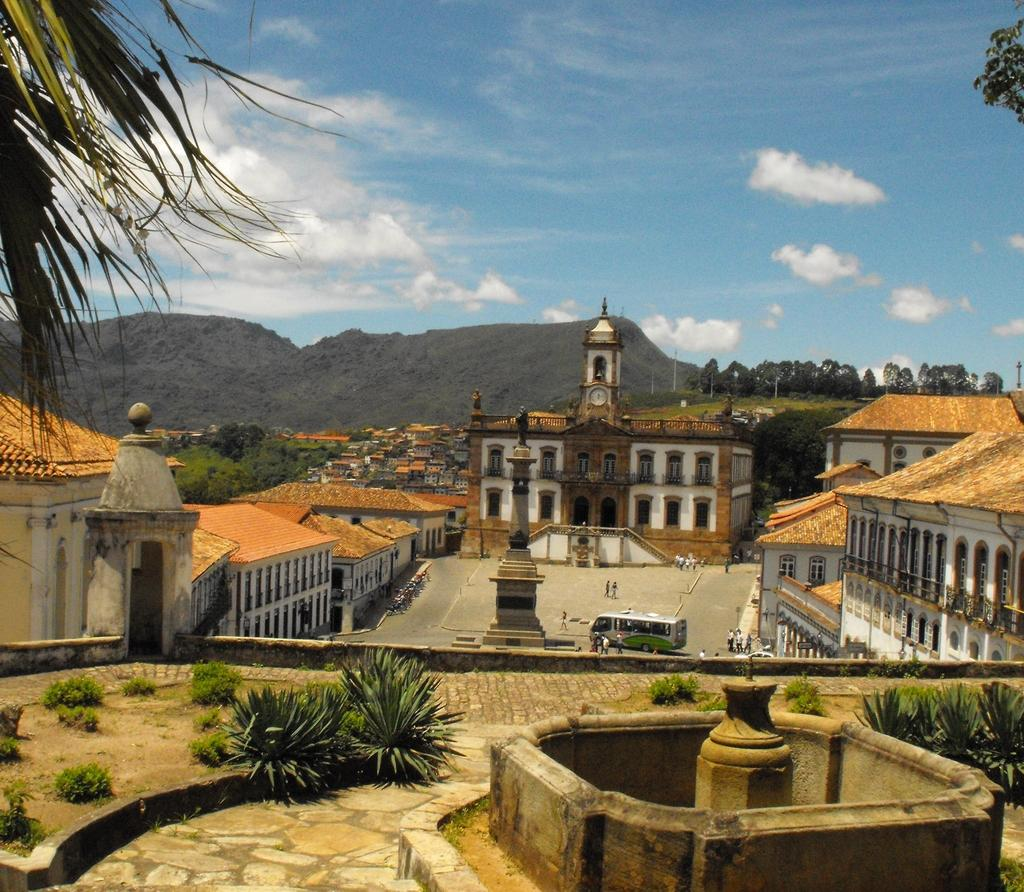What types of structures can be seen in the image? There are buildings in the image. What natural elements are present? There are plants, trees, and sky visible in the image. Can you describe any other objects in the image? There are other objects in the image, but their specific details are not mentioned in the facts. Are there any people visible in the image? Yes, there are people in the background of the image. What else can be seen in the background of the image? There is a bus and other objects visible in the background of the image. What question is being asked by the kittens in the image? There are no kittens present in the image, so no such question can be asked. What is the purpose of the bus in the image? The purpose of the bus in the image is not mentioned in the facts, so it cannot be determined from the image. 